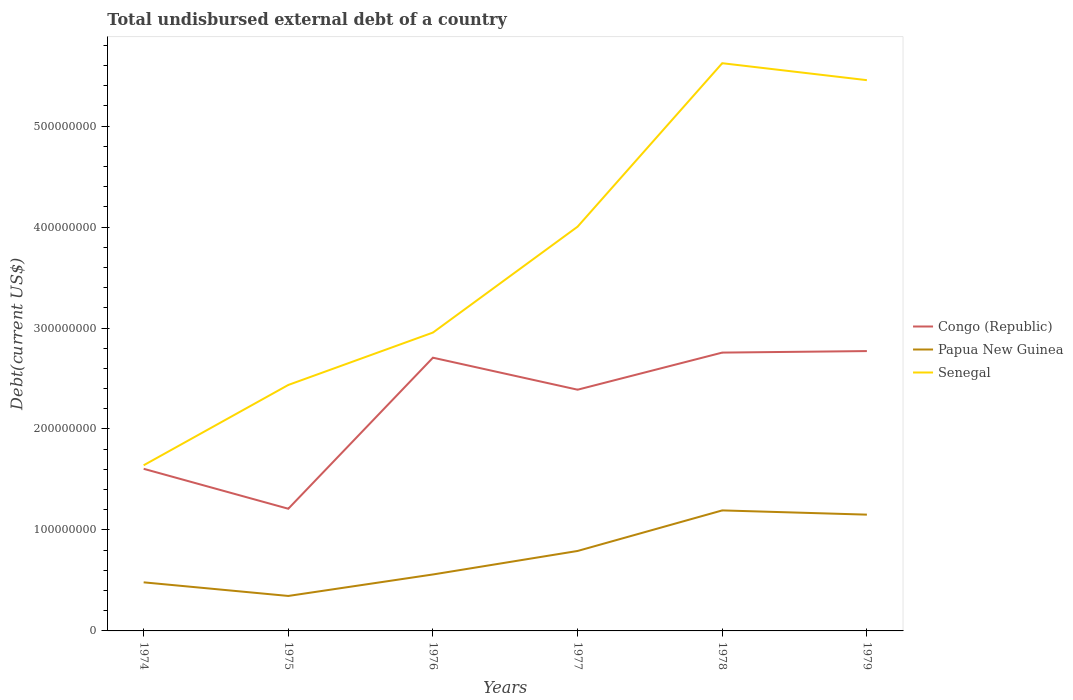Does the line corresponding to Papua New Guinea intersect with the line corresponding to Senegal?
Offer a very short reply. No. Across all years, what is the maximum total undisbursed external debt in Senegal?
Give a very brief answer. 1.64e+08. In which year was the total undisbursed external debt in Senegal maximum?
Your response must be concise. 1974. What is the total total undisbursed external debt in Congo (Republic) in the graph?
Offer a very short reply. -1.50e+08. What is the difference between the highest and the second highest total undisbursed external debt in Papua New Guinea?
Keep it short and to the point. 8.47e+07. Is the total undisbursed external debt in Papua New Guinea strictly greater than the total undisbursed external debt in Senegal over the years?
Your answer should be very brief. Yes. How many years are there in the graph?
Offer a very short reply. 6. Are the values on the major ticks of Y-axis written in scientific E-notation?
Offer a terse response. No. Does the graph contain grids?
Your answer should be compact. No. How are the legend labels stacked?
Your answer should be very brief. Vertical. What is the title of the graph?
Ensure brevity in your answer.  Total undisbursed external debt of a country. Does "Kazakhstan" appear as one of the legend labels in the graph?
Give a very brief answer. No. What is the label or title of the Y-axis?
Keep it short and to the point. Debt(current US$). What is the Debt(current US$) in Congo (Republic) in 1974?
Your answer should be very brief. 1.61e+08. What is the Debt(current US$) in Papua New Guinea in 1974?
Your response must be concise. 4.81e+07. What is the Debt(current US$) of Senegal in 1974?
Give a very brief answer. 1.64e+08. What is the Debt(current US$) of Congo (Republic) in 1975?
Offer a very short reply. 1.21e+08. What is the Debt(current US$) in Papua New Guinea in 1975?
Offer a terse response. 3.46e+07. What is the Debt(current US$) in Senegal in 1975?
Keep it short and to the point. 2.44e+08. What is the Debt(current US$) of Congo (Republic) in 1976?
Offer a very short reply. 2.71e+08. What is the Debt(current US$) in Papua New Guinea in 1976?
Make the answer very short. 5.59e+07. What is the Debt(current US$) in Senegal in 1976?
Keep it short and to the point. 2.95e+08. What is the Debt(current US$) of Congo (Republic) in 1977?
Keep it short and to the point. 2.39e+08. What is the Debt(current US$) of Papua New Guinea in 1977?
Your answer should be very brief. 7.92e+07. What is the Debt(current US$) of Senegal in 1977?
Give a very brief answer. 4.00e+08. What is the Debt(current US$) in Congo (Republic) in 1978?
Keep it short and to the point. 2.76e+08. What is the Debt(current US$) in Papua New Guinea in 1978?
Offer a very short reply. 1.19e+08. What is the Debt(current US$) of Senegal in 1978?
Give a very brief answer. 5.62e+08. What is the Debt(current US$) of Congo (Republic) in 1979?
Ensure brevity in your answer.  2.77e+08. What is the Debt(current US$) in Papua New Guinea in 1979?
Keep it short and to the point. 1.15e+08. What is the Debt(current US$) in Senegal in 1979?
Your answer should be very brief. 5.45e+08. Across all years, what is the maximum Debt(current US$) in Congo (Republic)?
Ensure brevity in your answer.  2.77e+08. Across all years, what is the maximum Debt(current US$) of Papua New Guinea?
Provide a succinct answer. 1.19e+08. Across all years, what is the maximum Debt(current US$) in Senegal?
Provide a succinct answer. 5.62e+08. Across all years, what is the minimum Debt(current US$) of Congo (Republic)?
Offer a very short reply. 1.21e+08. Across all years, what is the minimum Debt(current US$) in Papua New Guinea?
Your answer should be very brief. 3.46e+07. Across all years, what is the minimum Debt(current US$) in Senegal?
Your answer should be very brief. 1.64e+08. What is the total Debt(current US$) of Congo (Republic) in the graph?
Provide a succinct answer. 1.34e+09. What is the total Debt(current US$) of Papua New Guinea in the graph?
Make the answer very short. 4.52e+08. What is the total Debt(current US$) in Senegal in the graph?
Your response must be concise. 2.21e+09. What is the difference between the Debt(current US$) in Congo (Republic) in 1974 and that in 1975?
Your answer should be very brief. 3.96e+07. What is the difference between the Debt(current US$) in Papua New Guinea in 1974 and that in 1975?
Your answer should be very brief. 1.35e+07. What is the difference between the Debt(current US$) of Senegal in 1974 and that in 1975?
Make the answer very short. -7.95e+07. What is the difference between the Debt(current US$) of Congo (Republic) in 1974 and that in 1976?
Your answer should be compact. -1.10e+08. What is the difference between the Debt(current US$) of Papua New Guinea in 1974 and that in 1976?
Your response must be concise. -7.80e+06. What is the difference between the Debt(current US$) of Senegal in 1974 and that in 1976?
Provide a short and direct response. -1.31e+08. What is the difference between the Debt(current US$) of Congo (Republic) in 1974 and that in 1977?
Your response must be concise. -7.83e+07. What is the difference between the Debt(current US$) in Papua New Guinea in 1974 and that in 1977?
Offer a terse response. -3.11e+07. What is the difference between the Debt(current US$) of Senegal in 1974 and that in 1977?
Provide a succinct answer. -2.36e+08. What is the difference between the Debt(current US$) in Congo (Republic) in 1974 and that in 1978?
Ensure brevity in your answer.  -1.15e+08. What is the difference between the Debt(current US$) in Papua New Guinea in 1974 and that in 1978?
Your answer should be compact. -7.12e+07. What is the difference between the Debt(current US$) in Senegal in 1974 and that in 1978?
Provide a short and direct response. -3.98e+08. What is the difference between the Debt(current US$) in Congo (Republic) in 1974 and that in 1979?
Provide a short and direct response. -1.17e+08. What is the difference between the Debt(current US$) in Papua New Guinea in 1974 and that in 1979?
Provide a short and direct response. -6.71e+07. What is the difference between the Debt(current US$) in Senegal in 1974 and that in 1979?
Provide a succinct answer. -3.81e+08. What is the difference between the Debt(current US$) of Congo (Republic) in 1975 and that in 1976?
Offer a very short reply. -1.50e+08. What is the difference between the Debt(current US$) of Papua New Guinea in 1975 and that in 1976?
Provide a succinct answer. -2.13e+07. What is the difference between the Debt(current US$) in Senegal in 1975 and that in 1976?
Offer a terse response. -5.19e+07. What is the difference between the Debt(current US$) in Congo (Republic) in 1975 and that in 1977?
Provide a succinct answer. -1.18e+08. What is the difference between the Debt(current US$) of Papua New Guinea in 1975 and that in 1977?
Provide a succinct answer. -4.46e+07. What is the difference between the Debt(current US$) in Senegal in 1975 and that in 1977?
Provide a succinct answer. -1.57e+08. What is the difference between the Debt(current US$) of Congo (Republic) in 1975 and that in 1978?
Keep it short and to the point. -1.55e+08. What is the difference between the Debt(current US$) in Papua New Guinea in 1975 and that in 1978?
Keep it short and to the point. -8.47e+07. What is the difference between the Debt(current US$) of Senegal in 1975 and that in 1978?
Offer a very short reply. -3.19e+08. What is the difference between the Debt(current US$) of Congo (Republic) in 1975 and that in 1979?
Make the answer very short. -1.56e+08. What is the difference between the Debt(current US$) of Papua New Guinea in 1975 and that in 1979?
Offer a terse response. -8.05e+07. What is the difference between the Debt(current US$) in Senegal in 1975 and that in 1979?
Give a very brief answer. -3.02e+08. What is the difference between the Debt(current US$) in Congo (Republic) in 1976 and that in 1977?
Provide a succinct answer. 3.17e+07. What is the difference between the Debt(current US$) of Papua New Guinea in 1976 and that in 1977?
Give a very brief answer. -2.33e+07. What is the difference between the Debt(current US$) of Senegal in 1976 and that in 1977?
Your answer should be compact. -1.05e+08. What is the difference between the Debt(current US$) in Congo (Republic) in 1976 and that in 1978?
Offer a very short reply. -5.06e+06. What is the difference between the Debt(current US$) of Papua New Guinea in 1976 and that in 1978?
Give a very brief answer. -6.34e+07. What is the difference between the Debt(current US$) of Senegal in 1976 and that in 1978?
Keep it short and to the point. -2.67e+08. What is the difference between the Debt(current US$) in Congo (Republic) in 1976 and that in 1979?
Offer a terse response. -6.56e+06. What is the difference between the Debt(current US$) of Papua New Guinea in 1976 and that in 1979?
Your answer should be compact. -5.93e+07. What is the difference between the Debt(current US$) in Senegal in 1976 and that in 1979?
Your response must be concise. -2.50e+08. What is the difference between the Debt(current US$) of Congo (Republic) in 1977 and that in 1978?
Provide a short and direct response. -3.68e+07. What is the difference between the Debt(current US$) of Papua New Guinea in 1977 and that in 1978?
Give a very brief answer. -4.02e+07. What is the difference between the Debt(current US$) in Senegal in 1977 and that in 1978?
Provide a short and direct response. -1.62e+08. What is the difference between the Debt(current US$) in Congo (Republic) in 1977 and that in 1979?
Provide a succinct answer. -3.82e+07. What is the difference between the Debt(current US$) of Papua New Guinea in 1977 and that in 1979?
Give a very brief answer. -3.60e+07. What is the difference between the Debt(current US$) in Senegal in 1977 and that in 1979?
Your answer should be very brief. -1.45e+08. What is the difference between the Debt(current US$) in Congo (Republic) in 1978 and that in 1979?
Give a very brief answer. -1.50e+06. What is the difference between the Debt(current US$) of Papua New Guinea in 1978 and that in 1979?
Your response must be concise. 4.19e+06. What is the difference between the Debt(current US$) of Senegal in 1978 and that in 1979?
Make the answer very short. 1.68e+07. What is the difference between the Debt(current US$) in Congo (Republic) in 1974 and the Debt(current US$) in Papua New Guinea in 1975?
Keep it short and to the point. 1.26e+08. What is the difference between the Debt(current US$) of Congo (Republic) in 1974 and the Debt(current US$) of Senegal in 1975?
Keep it short and to the point. -8.30e+07. What is the difference between the Debt(current US$) of Papua New Guinea in 1974 and the Debt(current US$) of Senegal in 1975?
Your response must be concise. -1.95e+08. What is the difference between the Debt(current US$) of Congo (Republic) in 1974 and the Debt(current US$) of Papua New Guinea in 1976?
Provide a short and direct response. 1.05e+08. What is the difference between the Debt(current US$) of Congo (Republic) in 1974 and the Debt(current US$) of Senegal in 1976?
Offer a very short reply. -1.35e+08. What is the difference between the Debt(current US$) of Papua New Guinea in 1974 and the Debt(current US$) of Senegal in 1976?
Offer a very short reply. -2.47e+08. What is the difference between the Debt(current US$) of Congo (Republic) in 1974 and the Debt(current US$) of Papua New Guinea in 1977?
Your response must be concise. 8.14e+07. What is the difference between the Debt(current US$) of Congo (Republic) in 1974 and the Debt(current US$) of Senegal in 1977?
Provide a short and direct response. -2.40e+08. What is the difference between the Debt(current US$) in Papua New Guinea in 1974 and the Debt(current US$) in Senegal in 1977?
Your answer should be very brief. -3.52e+08. What is the difference between the Debt(current US$) in Congo (Republic) in 1974 and the Debt(current US$) in Papua New Guinea in 1978?
Offer a very short reply. 4.12e+07. What is the difference between the Debt(current US$) in Congo (Republic) in 1974 and the Debt(current US$) in Senegal in 1978?
Offer a very short reply. -4.02e+08. What is the difference between the Debt(current US$) of Papua New Guinea in 1974 and the Debt(current US$) of Senegal in 1978?
Give a very brief answer. -5.14e+08. What is the difference between the Debt(current US$) in Congo (Republic) in 1974 and the Debt(current US$) in Papua New Guinea in 1979?
Your answer should be compact. 4.54e+07. What is the difference between the Debt(current US$) of Congo (Republic) in 1974 and the Debt(current US$) of Senegal in 1979?
Make the answer very short. -3.85e+08. What is the difference between the Debt(current US$) in Papua New Guinea in 1974 and the Debt(current US$) in Senegal in 1979?
Offer a very short reply. -4.97e+08. What is the difference between the Debt(current US$) in Congo (Republic) in 1975 and the Debt(current US$) in Papua New Guinea in 1976?
Your answer should be very brief. 6.51e+07. What is the difference between the Debt(current US$) of Congo (Republic) in 1975 and the Debt(current US$) of Senegal in 1976?
Give a very brief answer. -1.74e+08. What is the difference between the Debt(current US$) in Papua New Guinea in 1975 and the Debt(current US$) in Senegal in 1976?
Offer a terse response. -2.61e+08. What is the difference between the Debt(current US$) in Congo (Republic) in 1975 and the Debt(current US$) in Papua New Guinea in 1977?
Give a very brief answer. 4.18e+07. What is the difference between the Debt(current US$) of Congo (Republic) in 1975 and the Debt(current US$) of Senegal in 1977?
Keep it short and to the point. -2.79e+08. What is the difference between the Debt(current US$) of Papua New Guinea in 1975 and the Debt(current US$) of Senegal in 1977?
Make the answer very short. -3.66e+08. What is the difference between the Debt(current US$) in Congo (Republic) in 1975 and the Debt(current US$) in Papua New Guinea in 1978?
Make the answer very short. 1.65e+06. What is the difference between the Debt(current US$) of Congo (Republic) in 1975 and the Debt(current US$) of Senegal in 1978?
Your answer should be very brief. -4.41e+08. What is the difference between the Debt(current US$) of Papua New Guinea in 1975 and the Debt(current US$) of Senegal in 1978?
Ensure brevity in your answer.  -5.28e+08. What is the difference between the Debt(current US$) in Congo (Republic) in 1975 and the Debt(current US$) in Papua New Guinea in 1979?
Ensure brevity in your answer.  5.84e+06. What is the difference between the Debt(current US$) of Congo (Republic) in 1975 and the Debt(current US$) of Senegal in 1979?
Your answer should be compact. -4.24e+08. What is the difference between the Debt(current US$) in Papua New Guinea in 1975 and the Debt(current US$) in Senegal in 1979?
Give a very brief answer. -5.11e+08. What is the difference between the Debt(current US$) in Congo (Republic) in 1976 and the Debt(current US$) in Papua New Guinea in 1977?
Your answer should be compact. 1.91e+08. What is the difference between the Debt(current US$) of Congo (Republic) in 1976 and the Debt(current US$) of Senegal in 1977?
Your answer should be very brief. -1.30e+08. What is the difference between the Debt(current US$) of Papua New Guinea in 1976 and the Debt(current US$) of Senegal in 1977?
Your answer should be compact. -3.44e+08. What is the difference between the Debt(current US$) in Congo (Republic) in 1976 and the Debt(current US$) in Papua New Guinea in 1978?
Your answer should be very brief. 1.51e+08. What is the difference between the Debt(current US$) of Congo (Republic) in 1976 and the Debt(current US$) of Senegal in 1978?
Your answer should be very brief. -2.92e+08. What is the difference between the Debt(current US$) of Papua New Guinea in 1976 and the Debt(current US$) of Senegal in 1978?
Make the answer very short. -5.06e+08. What is the difference between the Debt(current US$) in Congo (Republic) in 1976 and the Debt(current US$) in Papua New Guinea in 1979?
Offer a terse response. 1.55e+08. What is the difference between the Debt(current US$) of Congo (Republic) in 1976 and the Debt(current US$) of Senegal in 1979?
Offer a very short reply. -2.75e+08. What is the difference between the Debt(current US$) of Papua New Guinea in 1976 and the Debt(current US$) of Senegal in 1979?
Offer a terse response. -4.90e+08. What is the difference between the Debt(current US$) in Congo (Republic) in 1977 and the Debt(current US$) in Papua New Guinea in 1978?
Your response must be concise. 1.20e+08. What is the difference between the Debt(current US$) in Congo (Republic) in 1977 and the Debt(current US$) in Senegal in 1978?
Ensure brevity in your answer.  -3.23e+08. What is the difference between the Debt(current US$) of Papua New Guinea in 1977 and the Debt(current US$) of Senegal in 1978?
Your answer should be compact. -4.83e+08. What is the difference between the Debt(current US$) in Congo (Republic) in 1977 and the Debt(current US$) in Papua New Guinea in 1979?
Keep it short and to the point. 1.24e+08. What is the difference between the Debt(current US$) in Congo (Republic) in 1977 and the Debt(current US$) in Senegal in 1979?
Offer a terse response. -3.07e+08. What is the difference between the Debt(current US$) of Papua New Guinea in 1977 and the Debt(current US$) of Senegal in 1979?
Give a very brief answer. -4.66e+08. What is the difference between the Debt(current US$) of Congo (Republic) in 1978 and the Debt(current US$) of Papua New Guinea in 1979?
Provide a succinct answer. 1.60e+08. What is the difference between the Debt(current US$) of Congo (Republic) in 1978 and the Debt(current US$) of Senegal in 1979?
Provide a succinct answer. -2.70e+08. What is the difference between the Debt(current US$) of Papua New Guinea in 1978 and the Debt(current US$) of Senegal in 1979?
Give a very brief answer. -4.26e+08. What is the average Debt(current US$) of Congo (Republic) per year?
Provide a succinct answer. 2.24e+08. What is the average Debt(current US$) of Papua New Guinea per year?
Keep it short and to the point. 7.54e+07. What is the average Debt(current US$) of Senegal per year?
Your answer should be compact. 3.69e+08. In the year 1974, what is the difference between the Debt(current US$) in Congo (Republic) and Debt(current US$) in Papua New Guinea?
Provide a succinct answer. 1.12e+08. In the year 1974, what is the difference between the Debt(current US$) of Congo (Republic) and Debt(current US$) of Senegal?
Keep it short and to the point. -3.49e+06. In the year 1974, what is the difference between the Debt(current US$) of Papua New Guinea and Debt(current US$) of Senegal?
Keep it short and to the point. -1.16e+08. In the year 1975, what is the difference between the Debt(current US$) of Congo (Republic) and Debt(current US$) of Papua New Guinea?
Offer a terse response. 8.64e+07. In the year 1975, what is the difference between the Debt(current US$) in Congo (Republic) and Debt(current US$) in Senegal?
Make the answer very short. -1.23e+08. In the year 1975, what is the difference between the Debt(current US$) of Papua New Guinea and Debt(current US$) of Senegal?
Your response must be concise. -2.09e+08. In the year 1976, what is the difference between the Debt(current US$) of Congo (Republic) and Debt(current US$) of Papua New Guinea?
Give a very brief answer. 2.15e+08. In the year 1976, what is the difference between the Debt(current US$) of Congo (Republic) and Debt(current US$) of Senegal?
Provide a succinct answer. -2.49e+07. In the year 1976, what is the difference between the Debt(current US$) in Papua New Guinea and Debt(current US$) in Senegal?
Give a very brief answer. -2.40e+08. In the year 1977, what is the difference between the Debt(current US$) of Congo (Republic) and Debt(current US$) of Papua New Guinea?
Your response must be concise. 1.60e+08. In the year 1977, what is the difference between the Debt(current US$) of Congo (Republic) and Debt(current US$) of Senegal?
Offer a terse response. -1.61e+08. In the year 1977, what is the difference between the Debt(current US$) of Papua New Guinea and Debt(current US$) of Senegal?
Your answer should be very brief. -3.21e+08. In the year 1978, what is the difference between the Debt(current US$) of Congo (Republic) and Debt(current US$) of Papua New Guinea?
Your answer should be compact. 1.56e+08. In the year 1978, what is the difference between the Debt(current US$) of Congo (Republic) and Debt(current US$) of Senegal?
Give a very brief answer. -2.87e+08. In the year 1978, what is the difference between the Debt(current US$) of Papua New Guinea and Debt(current US$) of Senegal?
Your answer should be very brief. -4.43e+08. In the year 1979, what is the difference between the Debt(current US$) in Congo (Republic) and Debt(current US$) in Papua New Guinea?
Provide a succinct answer. 1.62e+08. In the year 1979, what is the difference between the Debt(current US$) in Congo (Republic) and Debt(current US$) in Senegal?
Offer a very short reply. -2.68e+08. In the year 1979, what is the difference between the Debt(current US$) of Papua New Guinea and Debt(current US$) of Senegal?
Give a very brief answer. -4.30e+08. What is the ratio of the Debt(current US$) of Congo (Republic) in 1974 to that in 1975?
Provide a succinct answer. 1.33. What is the ratio of the Debt(current US$) of Papua New Guinea in 1974 to that in 1975?
Ensure brevity in your answer.  1.39. What is the ratio of the Debt(current US$) of Senegal in 1974 to that in 1975?
Ensure brevity in your answer.  0.67. What is the ratio of the Debt(current US$) of Congo (Republic) in 1974 to that in 1976?
Ensure brevity in your answer.  0.59. What is the ratio of the Debt(current US$) of Papua New Guinea in 1974 to that in 1976?
Give a very brief answer. 0.86. What is the ratio of the Debt(current US$) of Senegal in 1974 to that in 1976?
Your answer should be compact. 0.56. What is the ratio of the Debt(current US$) in Congo (Republic) in 1974 to that in 1977?
Keep it short and to the point. 0.67. What is the ratio of the Debt(current US$) in Papua New Guinea in 1974 to that in 1977?
Your response must be concise. 0.61. What is the ratio of the Debt(current US$) of Senegal in 1974 to that in 1977?
Make the answer very short. 0.41. What is the ratio of the Debt(current US$) of Congo (Republic) in 1974 to that in 1978?
Your response must be concise. 0.58. What is the ratio of the Debt(current US$) in Papua New Guinea in 1974 to that in 1978?
Give a very brief answer. 0.4. What is the ratio of the Debt(current US$) in Senegal in 1974 to that in 1978?
Offer a terse response. 0.29. What is the ratio of the Debt(current US$) of Congo (Republic) in 1974 to that in 1979?
Provide a succinct answer. 0.58. What is the ratio of the Debt(current US$) in Papua New Guinea in 1974 to that in 1979?
Make the answer very short. 0.42. What is the ratio of the Debt(current US$) in Senegal in 1974 to that in 1979?
Your answer should be compact. 0.3. What is the ratio of the Debt(current US$) of Congo (Republic) in 1975 to that in 1976?
Your answer should be very brief. 0.45. What is the ratio of the Debt(current US$) in Papua New Guinea in 1975 to that in 1976?
Offer a terse response. 0.62. What is the ratio of the Debt(current US$) in Senegal in 1975 to that in 1976?
Your answer should be very brief. 0.82. What is the ratio of the Debt(current US$) in Congo (Republic) in 1975 to that in 1977?
Your answer should be compact. 0.51. What is the ratio of the Debt(current US$) of Papua New Guinea in 1975 to that in 1977?
Your answer should be compact. 0.44. What is the ratio of the Debt(current US$) of Senegal in 1975 to that in 1977?
Your answer should be compact. 0.61. What is the ratio of the Debt(current US$) in Congo (Republic) in 1975 to that in 1978?
Your answer should be compact. 0.44. What is the ratio of the Debt(current US$) in Papua New Guinea in 1975 to that in 1978?
Give a very brief answer. 0.29. What is the ratio of the Debt(current US$) of Senegal in 1975 to that in 1978?
Make the answer very short. 0.43. What is the ratio of the Debt(current US$) of Congo (Republic) in 1975 to that in 1979?
Your answer should be very brief. 0.44. What is the ratio of the Debt(current US$) in Papua New Guinea in 1975 to that in 1979?
Your answer should be very brief. 0.3. What is the ratio of the Debt(current US$) in Senegal in 1975 to that in 1979?
Make the answer very short. 0.45. What is the ratio of the Debt(current US$) of Congo (Republic) in 1976 to that in 1977?
Provide a short and direct response. 1.13. What is the ratio of the Debt(current US$) in Papua New Guinea in 1976 to that in 1977?
Offer a terse response. 0.71. What is the ratio of the Debt(current US$) of Senegal in 1976 to that in 1977?
Give a very brief answer. 0.74. What is the ratio of the Debt(current US$) of Congo (Republic) in 1976 to that in 1978?
Ensure brevity in your answer.  0.98. What is the ratio of the Debt(current US$) in Papua New Guinea in 1976 to that in 1978?
Ensure brevity in your answer.  0.47. What is the ratio of the Debt(current US$) in Senegal in 1976 to that in 1978?
Provide a succinct answer. 0.53. What is the ratio of the Debt(current US$) of Congo (Republic) in 1976 to that in 1979?
Offer a terse response. 0.98. What is the ratio of the Debt(current US$) of Papua New Guinea in 1976 to that in 1979?
Provide a succinct answer. 0.49. What is the ratio of the Debt(current US$) in Senegal in 1976 to that in 1979?
Your answer should be compact. 0.54. What is the ratio of the Debt(current US$) in Congo (Republic) in 1977 to that in 1978?
Your answer should be compact. 0.87. What is the ratio of the Debt(current US$) of Papua New Guinea in 1977 to that in 1978?
Keep it short and to the point. 0.66. What is the ratio of the Debt(current US$) in Senegal in 1977 to that in 1978?
Your answer should be compact. 0.71. What is the ratio of the Debt(current US$) in Congo (Republic) in 1977 to that in 1979?
Your answer should be very brief. 0.86. What is the ratio of the Debt(current US$) in Papua New Guinea in 1977 to that in 1979?
Ensure brevity in your answer.  0.69. What is the ratio of the Debt(current US$) of Senegal in 1977 to that in 1979?
Ensure brevity in your answer.  0.73. What is the ratio of the Debt(current US$) in Congo (Republic) in 1978 to that in 1979?
Keep it short and to the point. 0.99. What is the ratio of the Debt(current US$) of Papua New Guinea in 1978 to that in 1979?
Your answer should be very brief. 1.04. What is the ratio of the Debt(current US$) of Senegal in 1978 to that in 1979?
Provide a succinct answer. 1.03. What is the difference between the highest and the second highest Debt(current US$) of Congo (Republic)?
Give a very brief answer. 1.50e+06. What is the difference between the highest and the second highest Debt(current US$) of Papua New Guinea?
Ensure brevity in your answer.  4.19e+06. What is the difference between the highest and the second highest Debt(current US$) in Senegal?
Make the answer very short. 1.68e+07. What is the difference between the highest and the lowest Debt(current US$) of Congo (Republic)?
Ensure brevity in your answer.  1.56e+08. What is the difference between the highest and the lowest Debt(current US$) in Papua New Guinea?
Your answer should be very brief. 8.47e+07. What is the difference between the highest and the lowest Debt(current US$) of Senegal?
Offer a very short reply. 3.98e+08. 